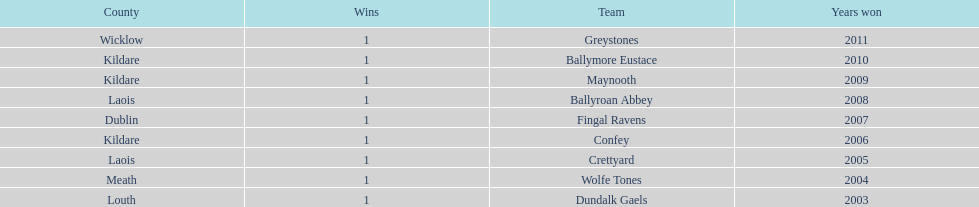Which is the first team from the chart Greystones. 